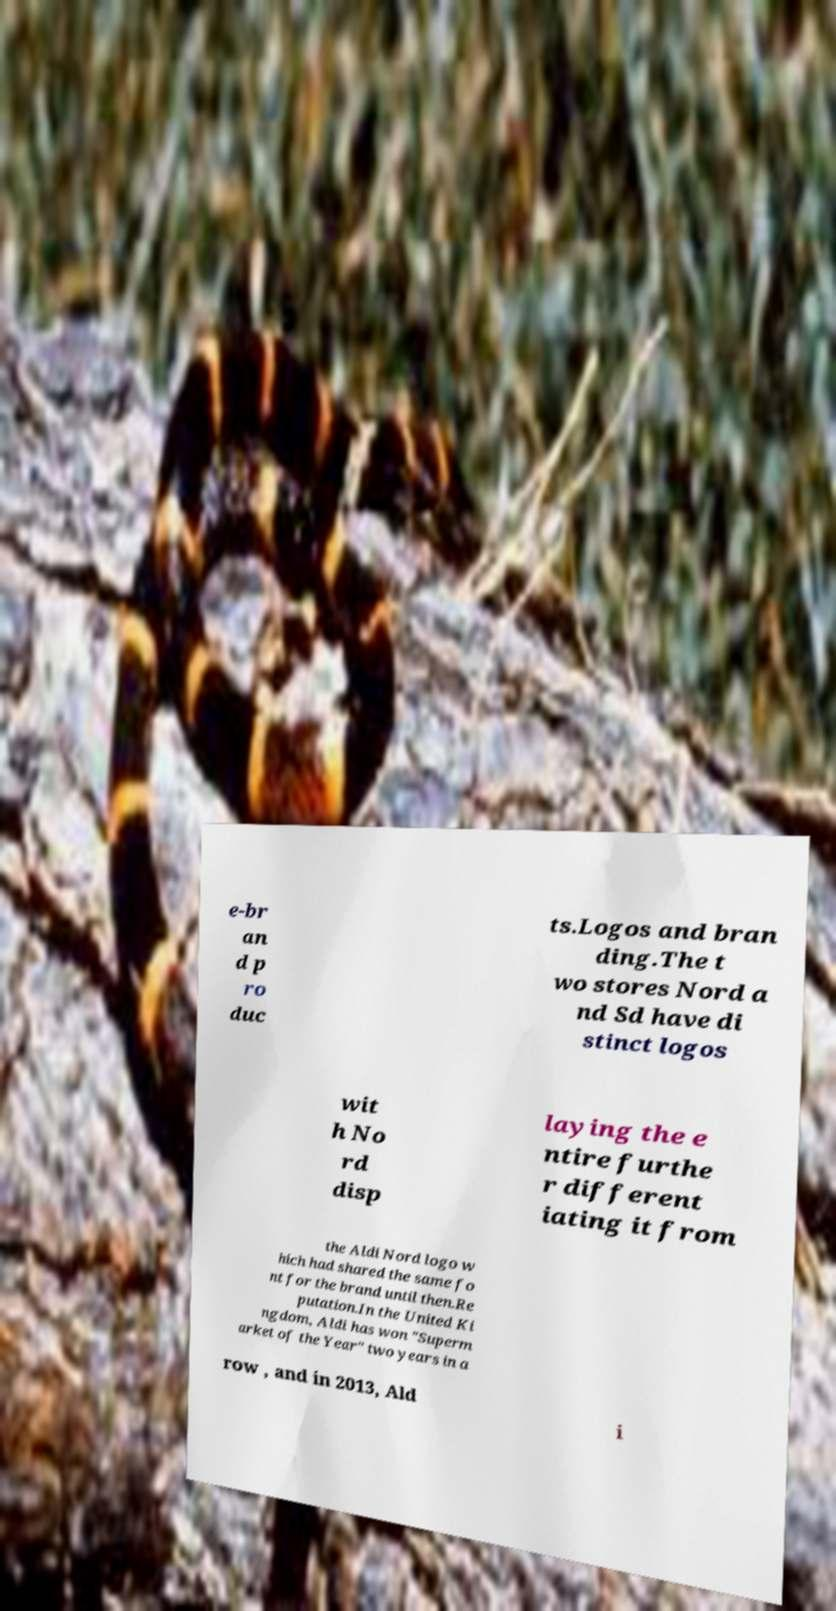What messages or text are displayed in this image? I need them in a readable, typed format. e-br an d p ro duc ts.Logos and bran ding.The t wo stores Nord a nd Sd have di stinct logos wit h No rd disp laying the e ntire furthe r different iating it from the Aldi Nord logo w hich had shared the same fo nt for the brand until then.Re putation.In the United Ki ngdom, Aldi has won "Superm arket of the Year" two years in a row , and in 2013, Ald i 